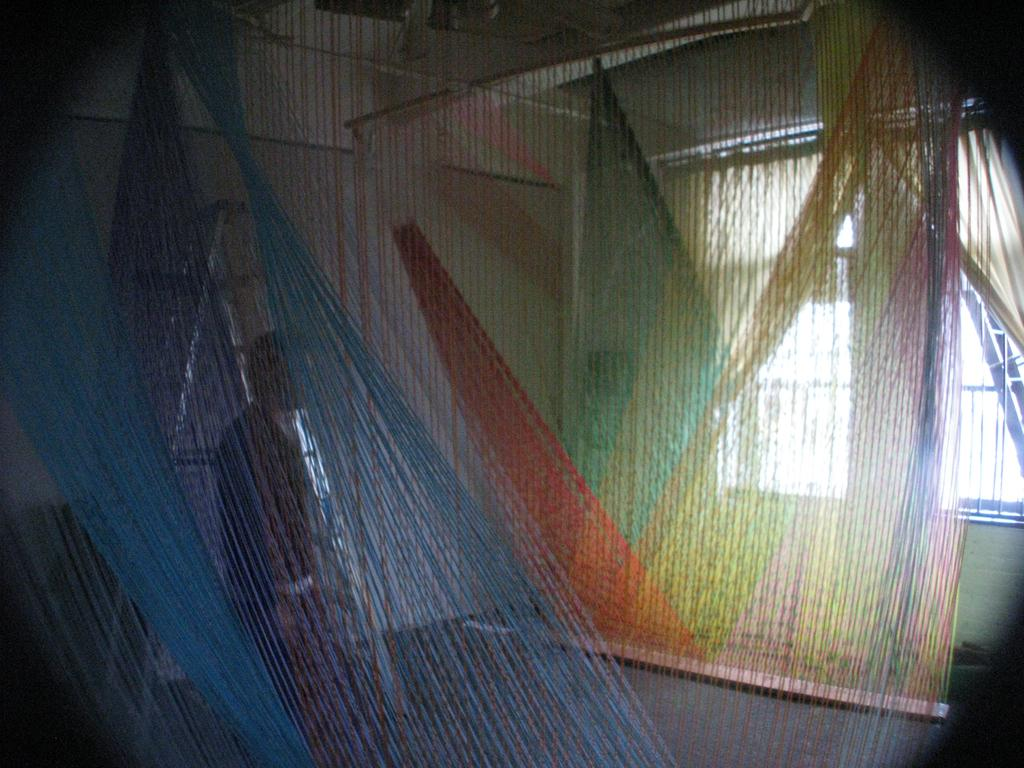What type of window treatment is visible in the image? There are curtains in the image. Where is the window located in the image? The window is on the right side of the image. What can be seen in the background of the image? There is a person, a ladder, and a wall in the background of the image. What type of bread is being used to solve arithmetic problems in the image? There is no bread or arithmetic problems present in the image. 